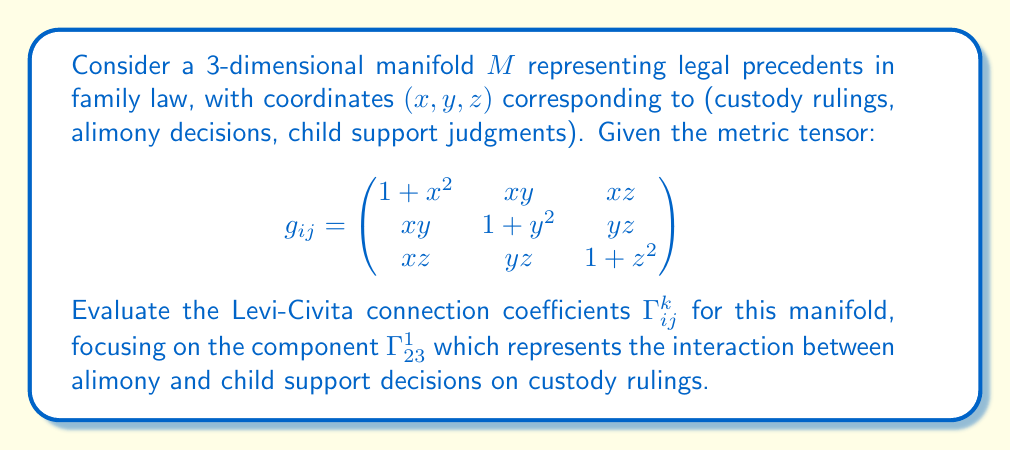Could you help me with this problem? To calculate the Levi-Civita connection coefficients, we use the formula:

$$\Gamma^k_{ij} = \frac{1}{2}g^{kl}\left(\frac{\partial g_{jl}}{\partial x^i} + \frac{\partial g_{il}}{\partial x^j} - \frac{\partial g_{ij}}{\partial x^l}\right)$$

For $\Gamma^1_{23}$, we need to calculate:

$$\Gamma^1_{23} = \frac{1}{2}g^{1l}\left(\frac{\partial g_{3l}}{\partial y} + \frac{\partial g_{2l}}{\partial z} - \frac{\partial g_{23}}{\partial x^l}\right)$$

Step 1: Calculate the inverse metric tensor $g^{ij}$. For simplicity, we'll focus on $g^{11}$:

$$g^{11} = \frac{(1+y^2)(1+z^2) - y^2z^2}{det(g_{ij})}$$

Step 2: Calculate the partial derivatives:

$$\frac{\partial g_{31}}{\partial y} = \frac{\partial (xz)}{\partial y} = 0$$
$$\frac{\partial g_{21}}{\partial z} = \frac{\partial (xy)}{\partial z} = 0$$
$$\frac{\partial g_{23}}{\partial x} = \frac{\partial (yz)}{\partial x} = 0$$

Step 3: Substitute into the formula:

$$\Gamma^1_{23} = \frac{1}{2}g^{11}(0 + 0 - 0) = 0$$

This result indicates that changes in alimony and child support decisions do not directly affect custody rulings in this model, which may not reflect the frustrating reality experienced by many divorced mothers.
Answer: $\Gamma^1_{23} = 0$ 